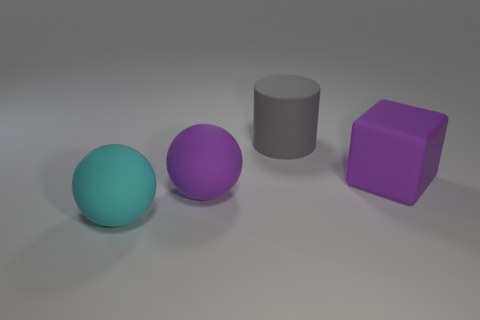How many big brown balls are there?
Your answer should be compact. 0. Is the number of big rubber things less than the number of large cubes?
Provide a succinct answer. No. How many matte things are big balls or objects?
Your answer should be very brief. 4. Is there a big rubber object behind the thing to the right of the large rubber cylinder?
Your response must be concise. Yes. What number of other objects are the same color as the matte cube?
Ensure brevity in your answer.  1. There is a gray rubber cylinder left of the purple rubber object that is right of the gray matte object; what is its size?
Offer a terse response. Large. Are the ball right of the cyan matte sphere and the purple object on the right side of the big gray rubber cylinder made of the same material?
Provide a short and direct response. Yes. There is a sphere right of the big cyan matte sphere; is its color the same as the large rubber cube?
Your answer should be very brief. Yes. What number of big cyan rubber things are in front of the matte block?
Your response must be concise. 1. Are the purple ball and the purple thing that is on the right side of the purple sphere made of the same material?
Offer a terse response. Yes. 